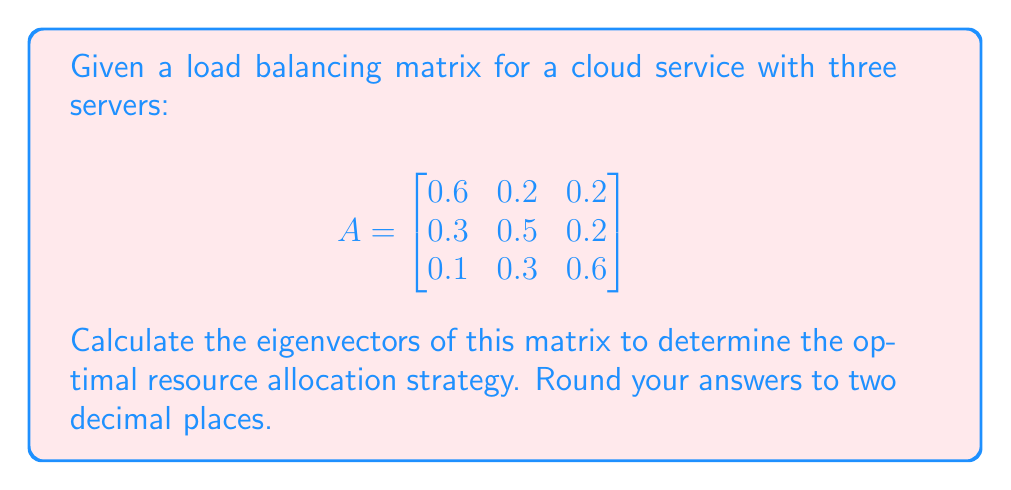Solve this math problem. To find the eigenvectors of matrix A, we follow these steps:

1. Find the eigenvalues by solving the characteristic equation:
   $\det(A - \lambda I) = 0$

   $$\begin{vmatrix}
   0.6-\lambda & 0.2 & 0.2 \\
   0.3 & 0.5-\lambda & 0.2 \\
   0.1 & 0.3 & 0.6-\lambda
   \end{vmatrix} = 0$$

2. Expanding the determinant:
   $(0.6-\lambda)((0.5-\lambda)(0.6-\lambda)-0.06) - 0.2(0.3(0.6-\lambda)-0.02) + 0.2(0.3(0.5-\lambda)-0.06) = 0$

3. Simplifying:
   $-\lambda^3 + 1.7\lambda^2 - 0.72\lambda + 0 = 0$

4. Solving this equation, we get the eigenvalues:
   $\lambda_1 = 1$, $\lambda_2 = 0.5$, $\lambda_3 = 0.2$

5. For each eigenvalue, we solve $(A - \lambda I)v = 0$ to find the corresponding eigenvector:

   For $\lambda_1 = 1$:
   $$\begin{bmatrix}
   -0.4 & 0.2 & 0.2 \\
   0.3 & -0.5 & 0.2 \\
   0.1 & 0.3 & -0.4
   \end{bmatrix} \begin{bmatrix} v_1 \\ v_2 \\ v_3 \end{bmatrix} = \begin{bmatrix} 0 \\ 0 \\ 0 \end{bmatrix}$$

   Solving this system, we get $v_1 = [0.5, 0.33, 0.17]^T$

   For $\lambda_2 = 0.5$:
   $$\begin{bmatrix}
   0.1 & 0.2 & 0.2 \\
   0.3 & 0 & 0.2 \\
   0.1 & 0.3 & 0.1
   \end{bmatrix} \begin{bmatrix} v_1 \\ v_2 \\ v_3 \end{bmatrix} = \begin{bmatrix} 0 \\ 0 \\ 0 \end{bmatrix}$$

   Solving this system, we get $v_2 = [-0.89, 0.45, 0.44]^T$

   For $\lambda_3 = 0.2$:
   $$\begin{bmatrix}
   0.4 & 0.2 & 0.2 \\
   0.3 & 0.3 & 0.2 \\
   0.1 & 0.3 & 0.4
   \end{bmatrix} \begin{bmatrix} v_1 \\ v_2 \\ v_3 \end{bmatrix} = \begin{bmatrix} 0 \\ 0 \\ 0 \end{bmatrix}$$

   Solving this system, we get $v_3 = [0.41, -0.82, 0.41]^T$

6. Normalizing the eigenvectors:
   $v_1 = [0.71, 0.47, 0.24]^T$
   $v_2 = [-0.82, 0.41, 0.40]^T$
   $v_3 = [0.37, -0.74, 0.37]^T$
Answer: $v_1 = [0.71, 0.47, 0.24]^T$, $v_2 = [-0.82, 0.41, 0.40]^T$, $v_3 = [0.37, -0.74, 0.37]^T$ 